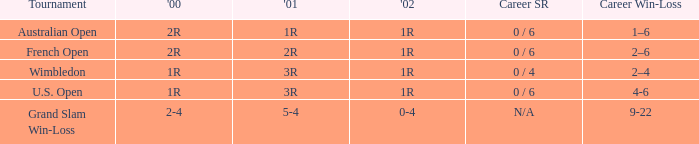In what year 2000 tournment did Angeles Montolio have a career win-loss record of 2-4? Grand Slam Win-Loss. 